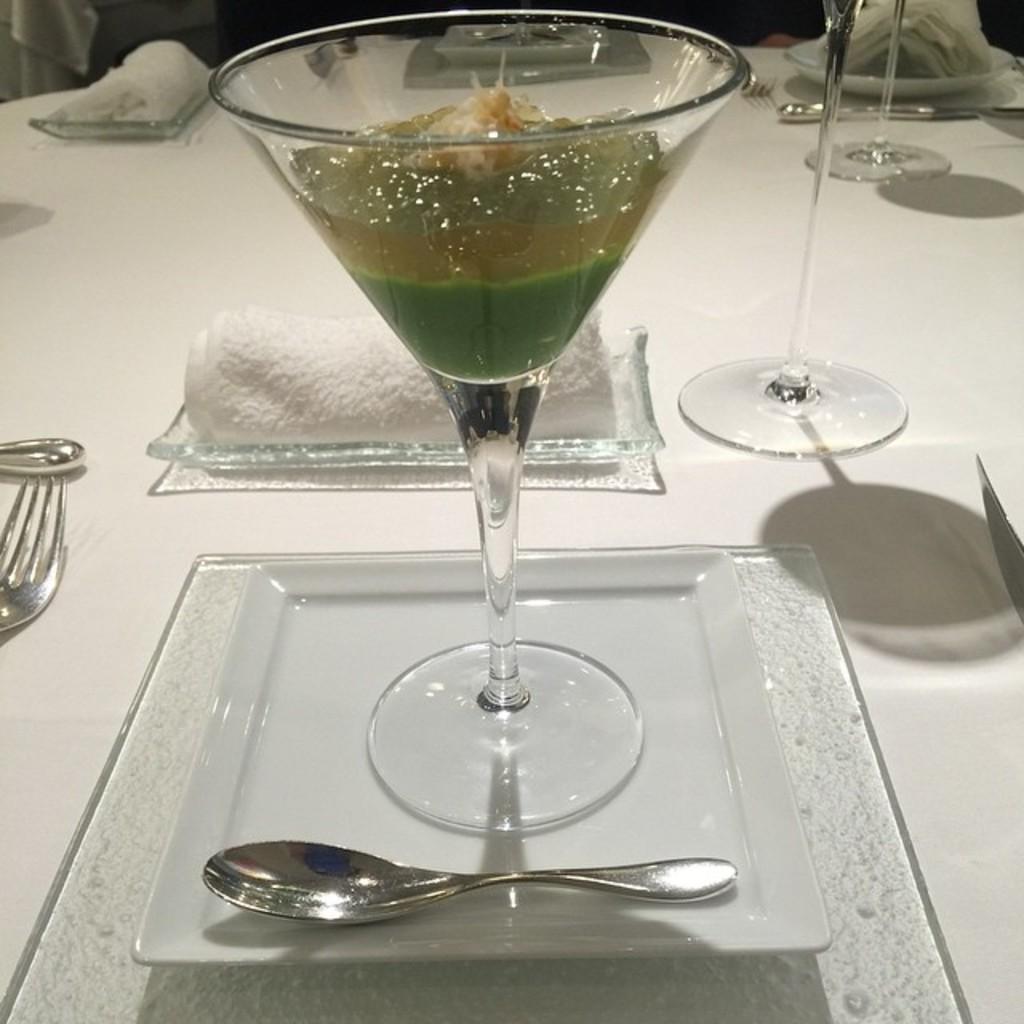How would you summarize this image in a sentence or two? In this picture there is a glass and it is kept on a table that has also a fork and a napkin kept on the table. 